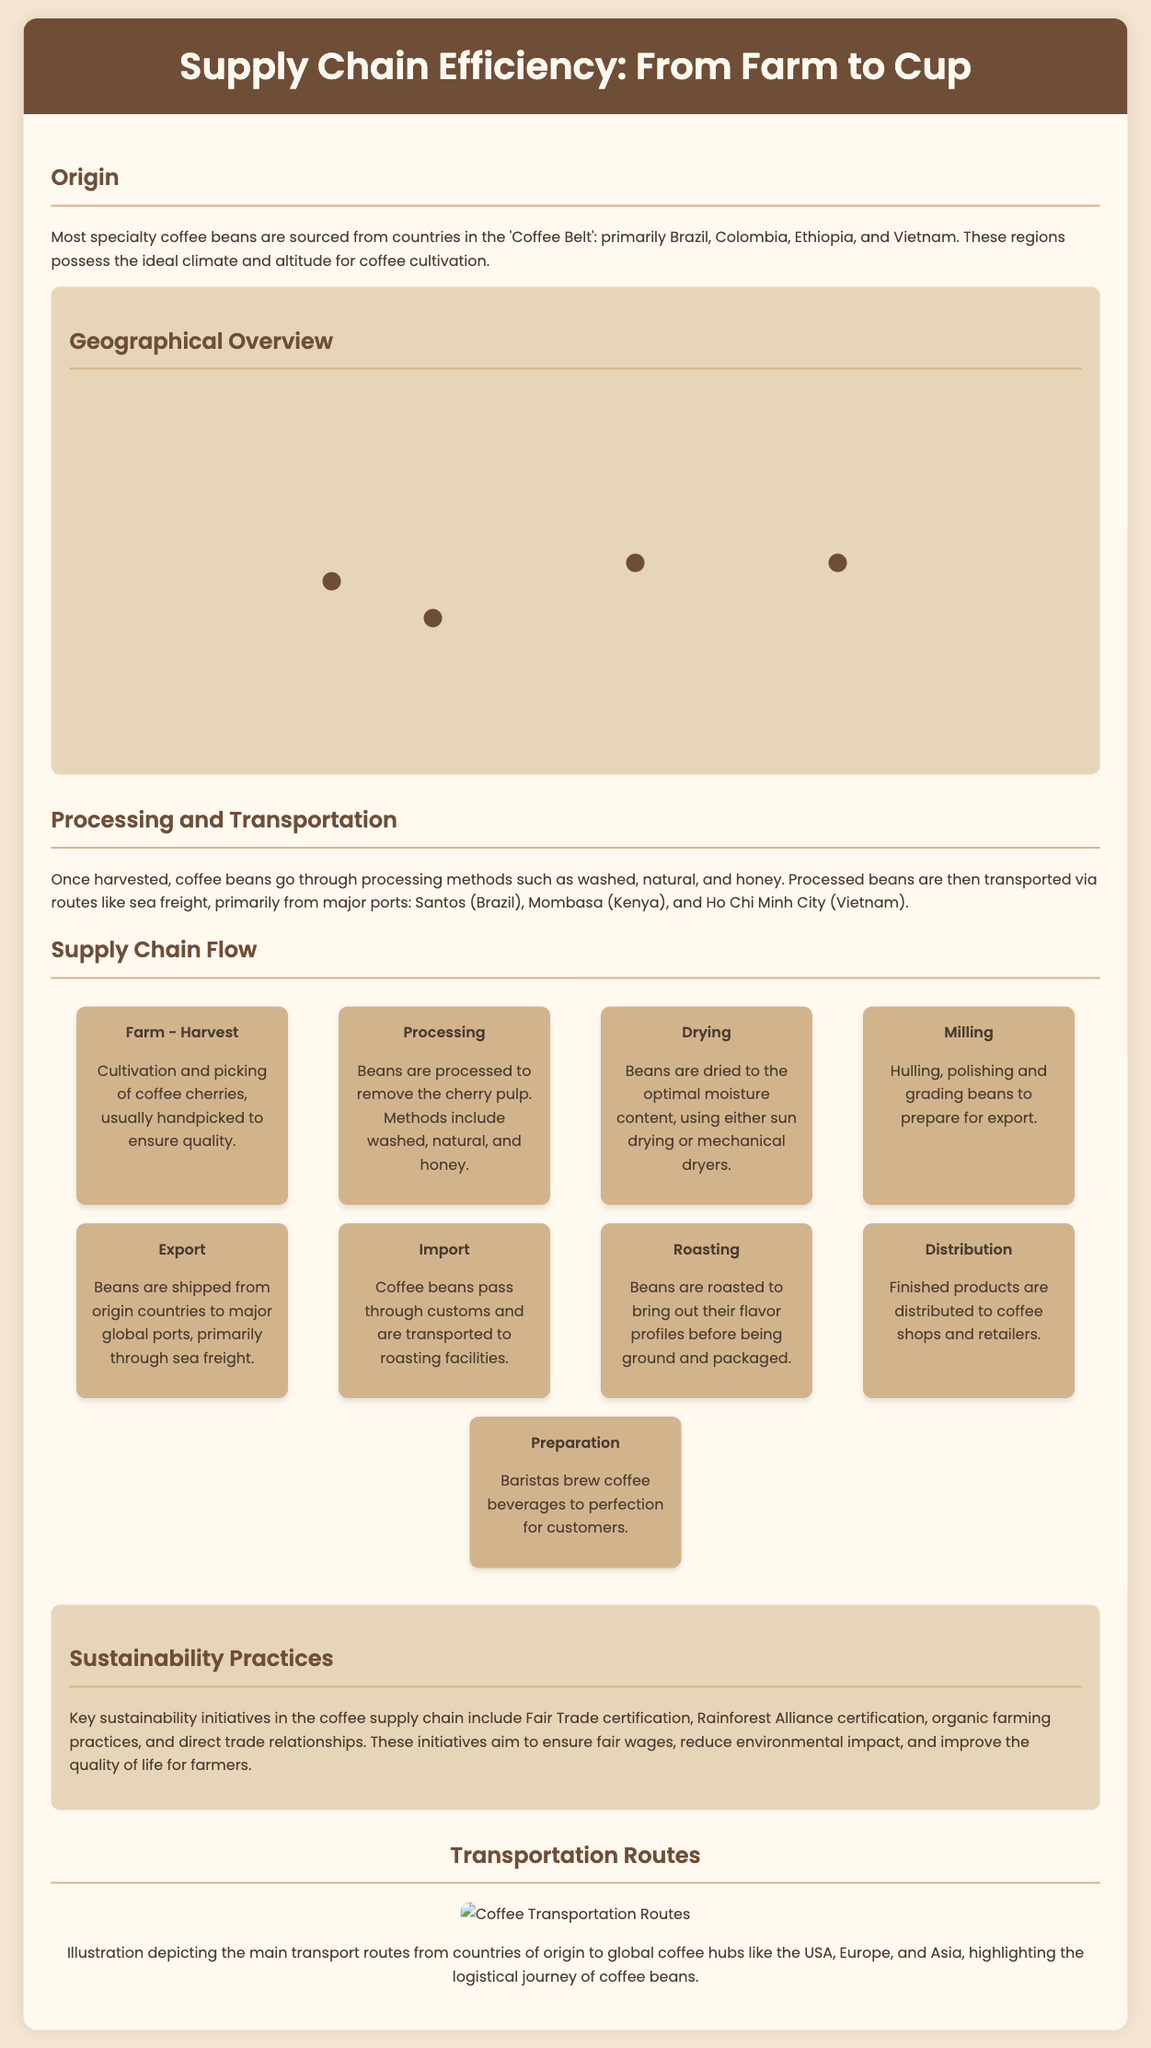What are the main coffee-producing countries? The document lists Brazil, Colombia, Ethiopia, and Vietnam as the primary coffee-producing countries in the Coffee Belt.
Answer: Brazil, Colombia, Ethiopia, Vietnam What is the primary transportation method for coffee beans after processing? The document states that processed beans are transported primarily via sea freight.
Answer: Sea freight Which country is known as the birthplace of coffee? According to the document, Ethiopia is referred to as the birthplace of coffee.
Answer: Ethiopia What certification ensures fair wages for coffee farmers? The document mentions Fair Trade certification as a key initiative for fair wages.
Answer: Fair Trade How many nodes are in the supply chain flow section? The document outlines a total of eight nodes in the supply chain flow.
Answer: Eight Which processing method involves removing the cherry pulp? The document specifies that processing is the stage at which the cherry pulp is removed from the beans.
Answer: Processing What percentage of coffee is typically sourced from Brazil? The document does not specify a percentage but labels Brazil as the largest coffee producer.
Answer: Largest producer Which sustainability initiative focuses on reducing environmental impact? The document discusses organic farming practices among key sustainability initiatives in the coffee supply chain.
Answer: Organic farming practices Where are the main coffee transport routes depicted? The document provides a transportation routes illustration showing global coffee hubs such as the USA, Europe, and Asia.
Answer: Global coffee hubs 